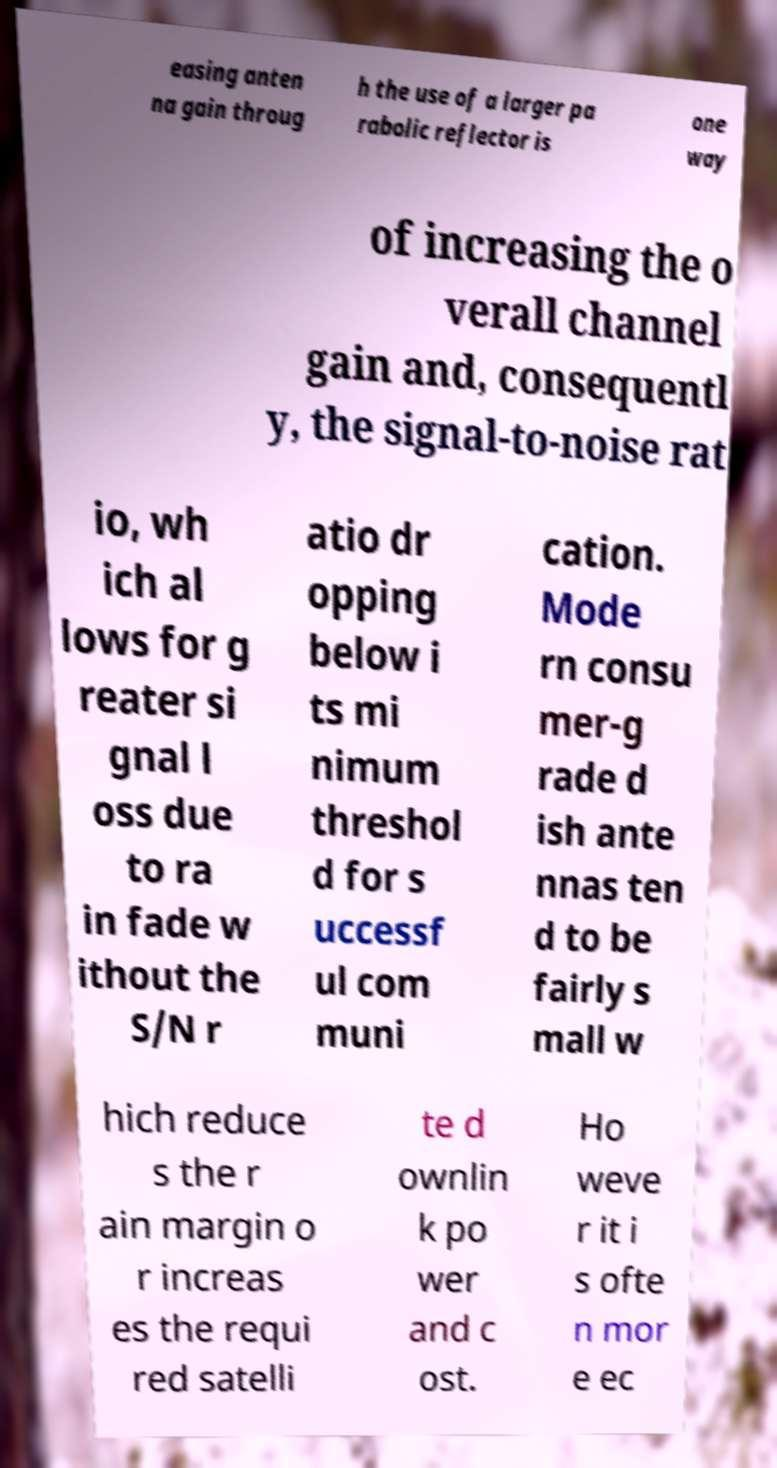Please identify and transcribe the text found in this image. easing anten na gain throug h the use of a larger pa rabolic reflector is one way of increasing the o verall channel gain and, consequentl y, the signal-to-noise rat io, wh ich al lows for g reater si gnal l oss due to ra in fade w ithout the S/N r atio dr opping below i ts mi nimum threshol d for s uccessf ul com muni cation. Mode rn consu mer-g rade d ish ante nnas ten d to be fairly s mall w hich reduce s the r ain margin o r increas es the requi red satelli te d ownlin k po wer and c ost. Ho weve r it i s ofte n mor e ec 